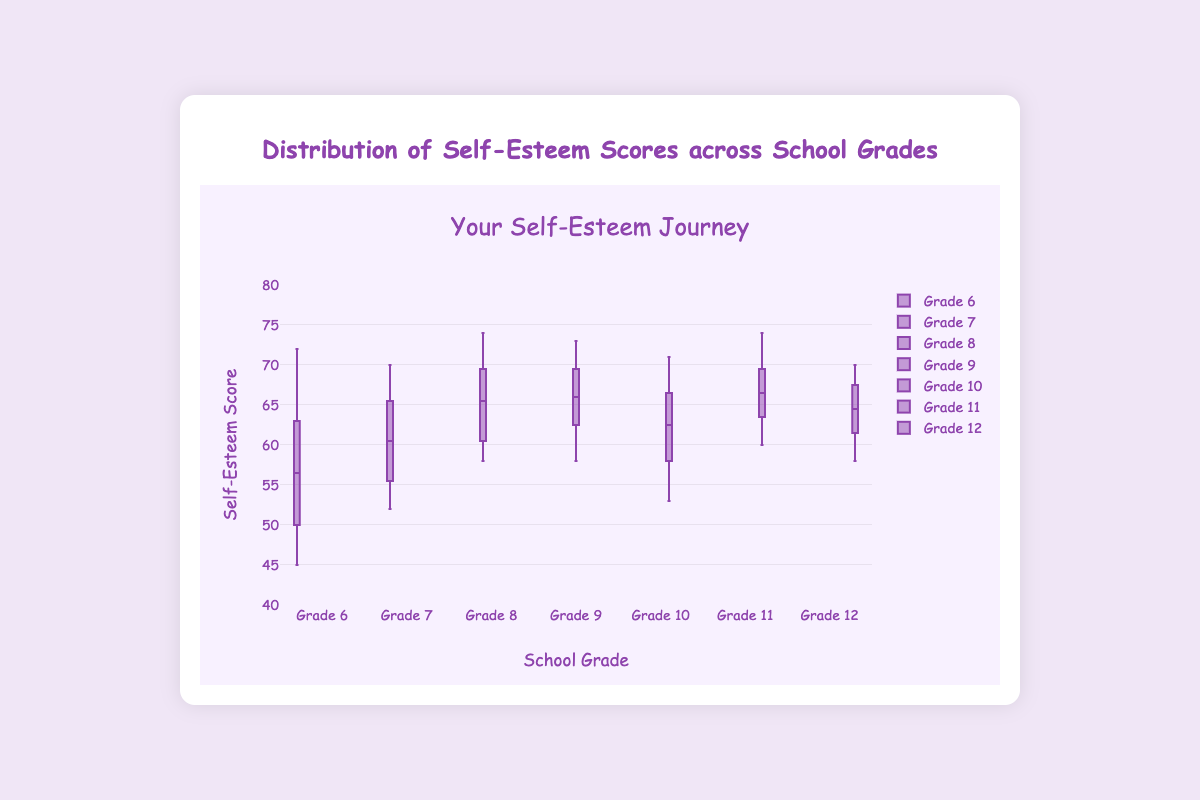What is the range of self-esteem scores for Grade 6? The range of self-esteem scores is the difference between the maximum and minimum scores. For Grade 6, the maximum score is 72 and the minimum score is 45. Therefore, the range is 72 - 45.
Answer: 27 Which grade has the highest median self-esteem score? To find the highest median score, we need to look at the median line inside each box plot. Of all the grades, Grade 11 has the highest median score, which is around 66.
Answer: Grade 11 What is the interquartile range (IQR) for Grade 7's self-esteem scores? The interquartile range is the difference between the third quartile (Q3) and the first quartile (Q1). For Grade 7, Q3 is approximately 66 and Q1 is approximately 54. Therefore, the IQR is 66 - 54.
Answer: 12 Which grade has the smallest spread in self-esteem scores? The spread of self-esteem scores can be identified by the size of the box. Grade 10 has the smallest box, indicating the smallest spread, which means its scores are more tightly clustered.
Answer: Grade 10 Are there any grades with outliers? If yes, which ones? Outliers in box plots are generally points that fall outside the whiskers. For the given data, Grade 6 has an outlier around the score of 45.
Answer: Grade 6 Which grade has the lowest minimum self-esteem score? Minimum scores are identified by the bottom whisker or outliers below it. Grade 6 has the lowest minimum score, which is 45.
Answer: Grade 6 How do the median self-esteem scores for Grade 9 and Grade 10 compare? The median for each grade is indicated by the line inside the box. Grade 9 has a median of around 65, while Grade 10 has a median of around 62. Therefore, Grade 9 has a higher median score.
Answer: Grade 9 What is the range of the third quartile (Q3) values across all grades? The third quartile (Q3) values vary across the grades. The highest Q3 value is about 72 (Grades 8 and 11), and the lowest Q3 value is about 67 (Grade 10). Therefore, the range is 72 - 67.
Answer: 5 Do any grades have matching medians? If yes, which ones? By looking at the median lines inside the boxes, both Grade 9 and Grade 12 have medians that appear to be approximately 64 (the same value).
Answer: Grade 9 and Grade 12 Which grade shows the highest maximum self-esteem score? The maximum score is represented by the top whisker or the highest point. Grade 11 has the highest maximum score, which is 74.
Answer: Grade 11 